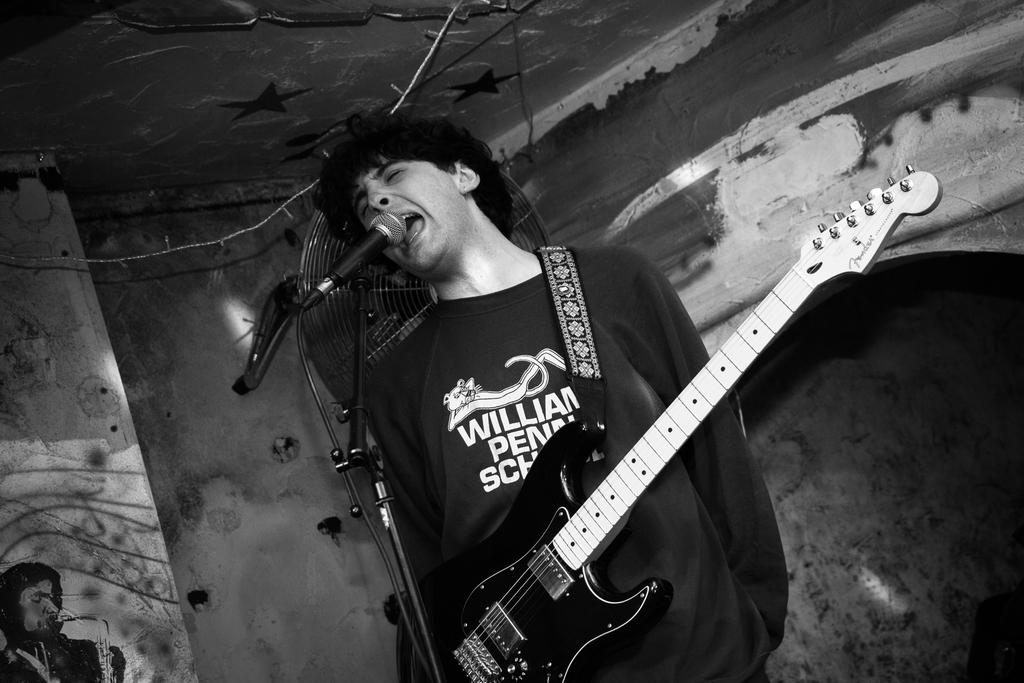What is the main subject of the image? There is a person in the image. What is the person doing in the image? The person is standing on a mic. What is the person wearing in the image? The person is wearing a guitar. What color are the person's eyes in the image? The provided facts do not mention the person's eyes, so we cannot determine their color from the image. What is the person using to hammer in the image? There is no hammer present in the image. 